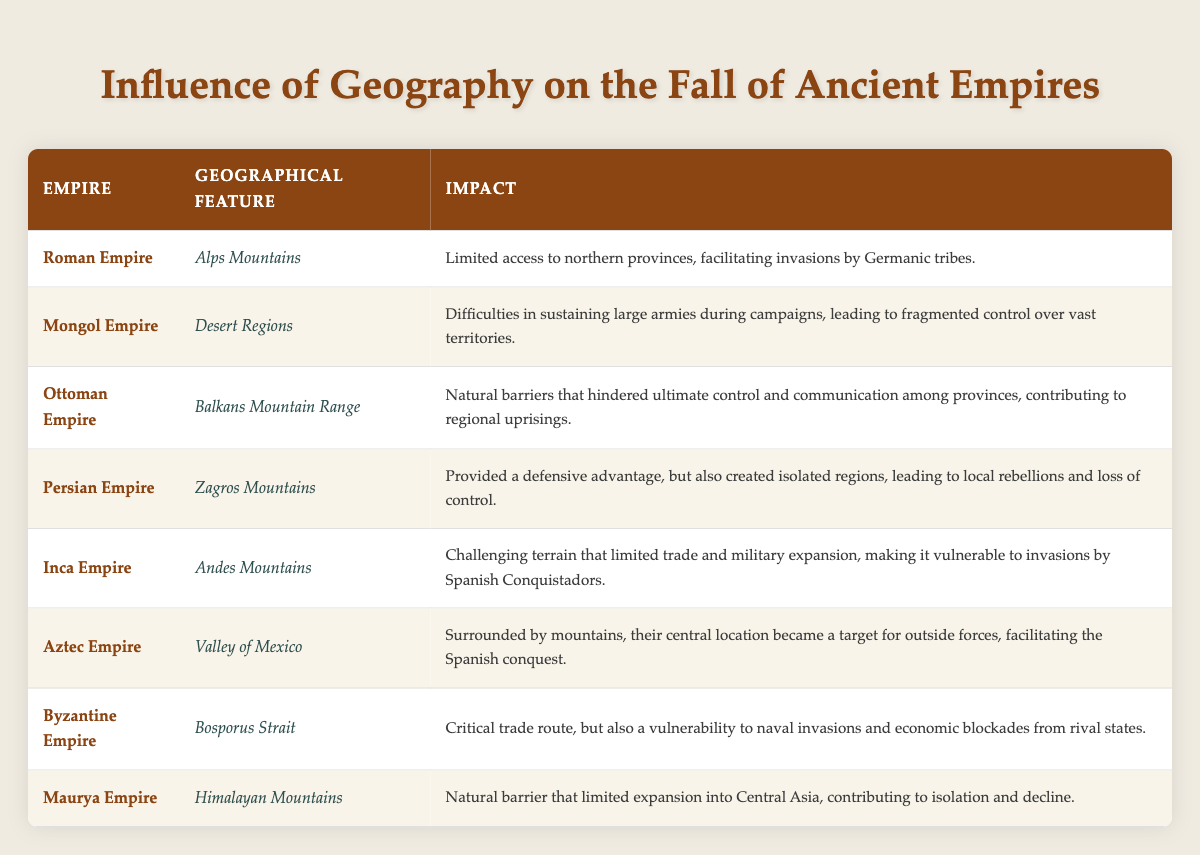What geographical feature limited the Roman Empire’s access to northern provinces? The table specifies that the Alps Mountains were the geographical feature limiting access for the Roman Empire.
Answer: Alps Mountains Which empire faced difficulties in sustaining large armies due to desert regions? According to the table, the Mongol Empire is noted for having difficulties in sustaining large armies during campaigns because of the desert regions.
Answer: Mongol Empire Did the Ottoman Empire's geographical features aid in control over its provinces? The table indicates that the Balkans Mountain Range hindered control and communication among provinces for the Ottoman Empire, implying it did not aid in governance.
Answer: No Which empire experienced regional uprisings as a direct impact of its geographical features? The Ottoman Empire is noted in the table as experiencing regional uprisings due to natural barriers that hindered control and communication.
Answer: Ottoman Empire What is the impact of the Andes Mountains on the Inca Empire? The table states that the Andes Mountains presented challenging terrain that limited trade and military expansion for the Inca Empire, making it vulnerable to invasions.
Answer: Limited trade and military expansion List the empires that had natural barriers impacting their expansion into other regions. By analyzing the table, the Persian Empire (Zagros Mountains) and the Maurya Empire (Himalayan Mountains) both had natural barriers affecting their expansion.
Answer: Persian Empire, Maurya Empire Which empire’s central location became a target for outside forces facilitating conquest? The table specifies that the Aztec Empire's central location in the Valley of Mexico made it a target for outside forces, paving the way for the Spanish conquest.
Answer: Aztec Empire What was the defensive advantage offered by the Zagros Mountains? The table mentions that the Zagros Mountains provided a defensive advantage for the Persian Empire but also created isolated regions leading to rebellions.
Answer: Defensive advantage, but isolation Which two empires faced issues related to communication and control due to their geographical features? The Ottoman Empire faced issues with communication and control due to the Balkans Mountain Range, and the Byzantine Empire faced similar issues due to the Bosporus Strait.
Answer: Ottoman Empire, Byzantine Empire Can you identify an empire whose geographical challenges limited trade and military expansion, making it particularly vulnerable? The Inca Empire is noted for having challenging terrain in the Andes Mountains, which limited trade and military expansion, making it vulnerable to invasions.
Answer: Inca Empire How did the Bosporus Strait impact the Byzantine Empire? The table specifies that the Bosporus Strait served as a critical trade route for the Byzantine Empire but also made it vulnerable to naval invasions and economic blockades.
Answer: Critical trade route with vulnerabilities 